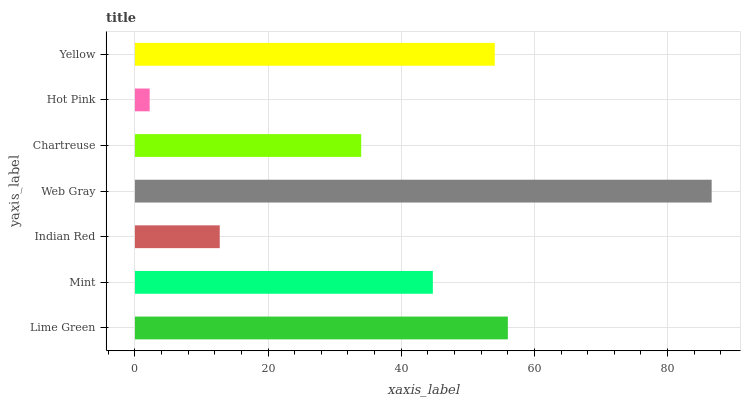Is Hot Pink the minimum?
Answer yes or no. Yes. Is Web Gray the maximum?
Answer yes or no. Yes. Is Mint the minimum?
Answer yes or no. No. Is Mint the maximum?
Answer yes or no. No. Is Lime Green greater than Mint?
Answer yes or no. Yes. Is Mint less than Lime Green?
Answer yes or no. Yes. Is Mint greater than Lime Green?
Answer yes or no. No. Is Lime Green less than Mint?
Answer yes or no. No. Is Mint the high median?
Answer yes or no. Yes. Is Mint the low median?
Answer yes or no. Yes. Is Hot Pink the high median?
Answer yes or no. No. Is Chartreuse the low median?
Answer yes or no. No. 